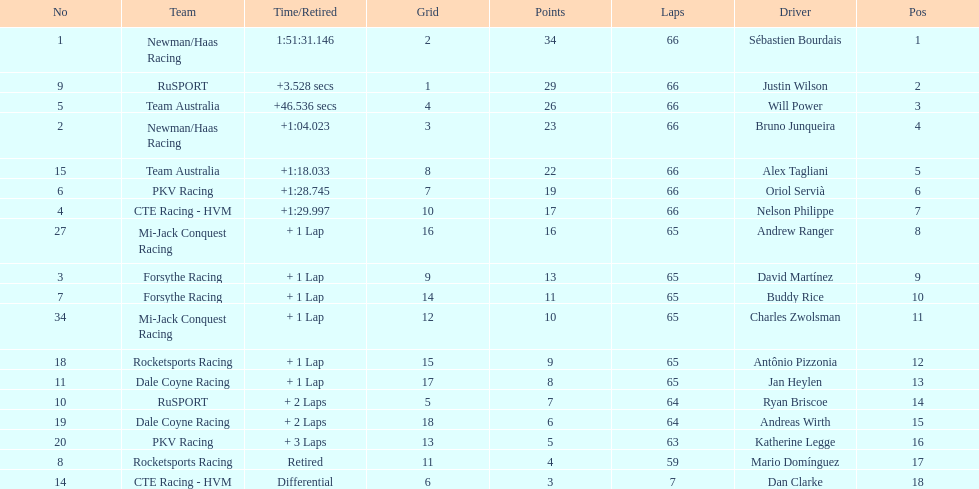Who finished directly after the driver who finished in 1:28.745? Nelson Philippe. 